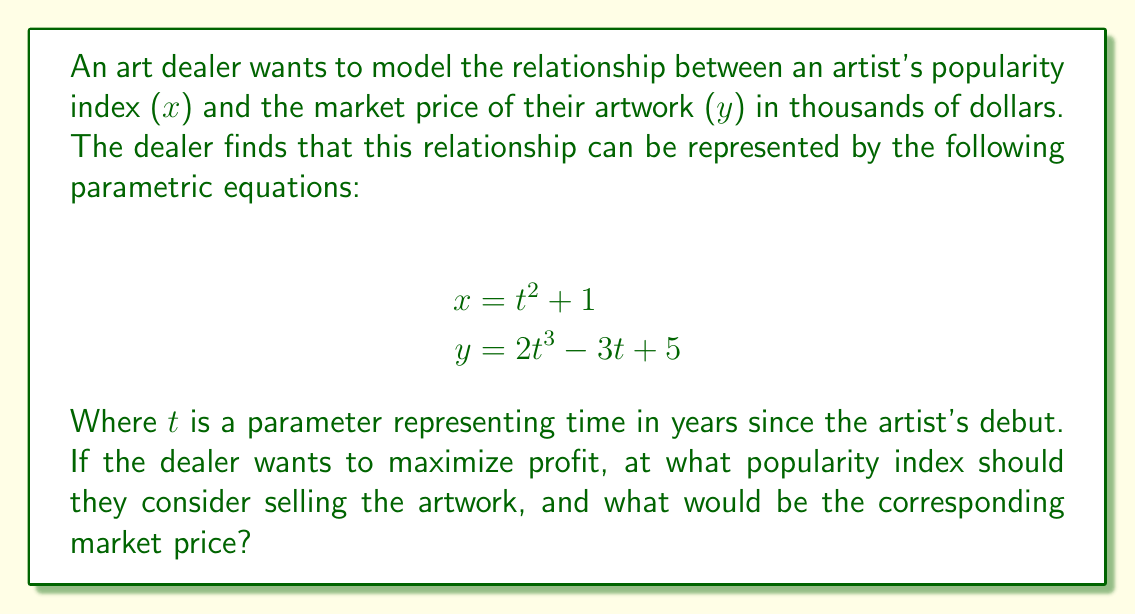Can you solve this math problem? To solve this problem, we need to find the point where the rate of change of price with respect to popularity is maximized. This occurs when $\frac{dy}{dx}$ is at its maximum.

1) First, we need to find $\frac{dy}{dx}$ using the chain rule:

   $\frac{dy}{dx} = \frac{dy/dt}{dx/dt}$

2) Calculate $\frac{dx}{dt}$ and $\frac{dy}{dt}$:
   
   $\frac{dx}{dt} = 2t$
   $\frac{dy}{dt} = 6t^2 - 3$

3) Now we can express $\frac{dy}{dx}$:

   $\frac{dy}{dx} = \frac{6t^2 - 3}{2t} = 3t - \frac{3}{2t}$

4) To find the maximum of $\frac{dy}{dx}$, we differentiate it with respect to t and set it to zero:

   $\frac{d}{dt}(3t - \frac{3}{2t}) = 3 + \frac{3}{2t^2} = 0$

5) Solving this equation:

   $3 + \frac{3}{2t^2} = 0$
   $\frac{3}{2t^2} = -3$
   $t^2 = -\frac{1}{2}$
   $t = \pm \frac{i}{\sqrt{2}}$

6) Since t represents time, we're only interested in real solutions. The function $\frac{dy}{dx}$ has no real critical points, which means its maximum occurs at the endpoint of the domain. As t approaches infinity, $\frac{dy}{dx}$ approaches 3.

7) Therefore, the dealer should sell when the popularity index is as high as possible. As t approaches infinity:

   $x = t^2 + 1 \rightarrow \infty$
   $y = 2t^3 - 3t + 5 \rightarrow \infty$

8) However, for a practical answer, we can choose a large value of t, say t = 10:

   $x = 10^2 + 1 = 101$
   $y = 2(10^3) - 3(10) + 5 = 1,975$
Answer: The art dealer should consider selling when the artist's popularity index is very high, ideally approaching 101 or higher. The corresponding market price would be approaching $1,975,000 or higher. 